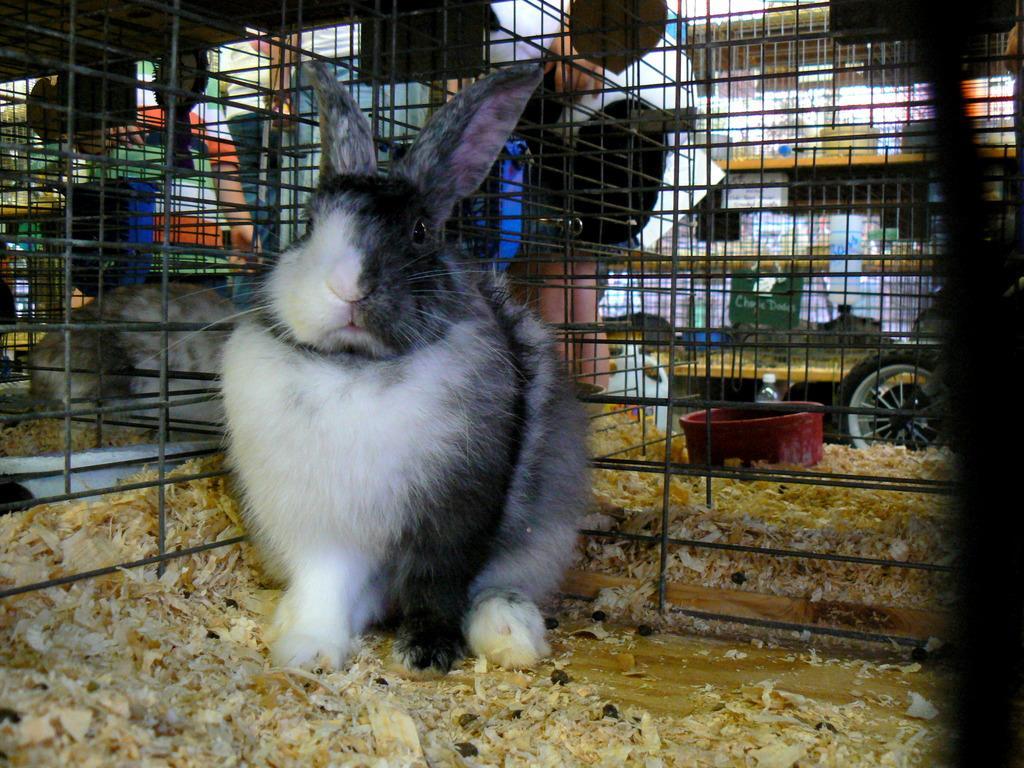How would you summarize this image in a sentence or two? In this image we can see rabbits in the cages, there is a person near the cage, a bowl in the cage and there is a bottle, in the background it looks like a building, few objects an a vehicle. 